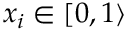<formula> <loc_0><loc_0><loc_500><loc_500>x _ { i } \in [ 0 , 1 \rangle</formula> 